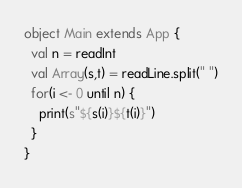<code> <loc_0><loc_0><loc_500><loc_500><_Scala_>object Main extends App {
  val n = readInt
  val Array(s,t) = readLine.split(" ")
  for(i <- 0 until n) {
    print(s"${s(i)}${t(i)}")
  }
}</code> 